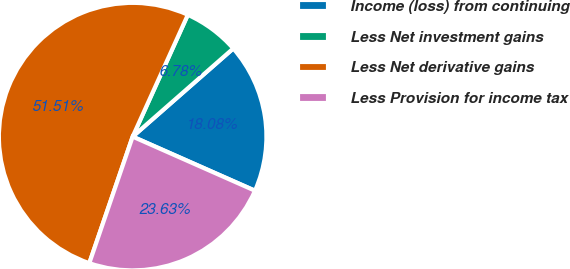Convert chart. <chart><loc_0><loc_0><loc_500><loc_500><pie_chart><fcel>Income (loss) from continuing<fcel>Less Net investment gains<fcel>Less Net derivative gains<fcel>Less Provision for income tax<nl><fcel>18.08%<fcel>6.78%<fcel>51.52%<fcel>23.63%<nl></chart> 